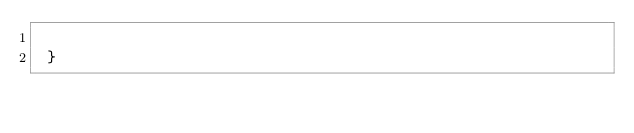<code> <loc_0><loc_0><loc_500><loc_500><_Cuda_>
 }


</code> 